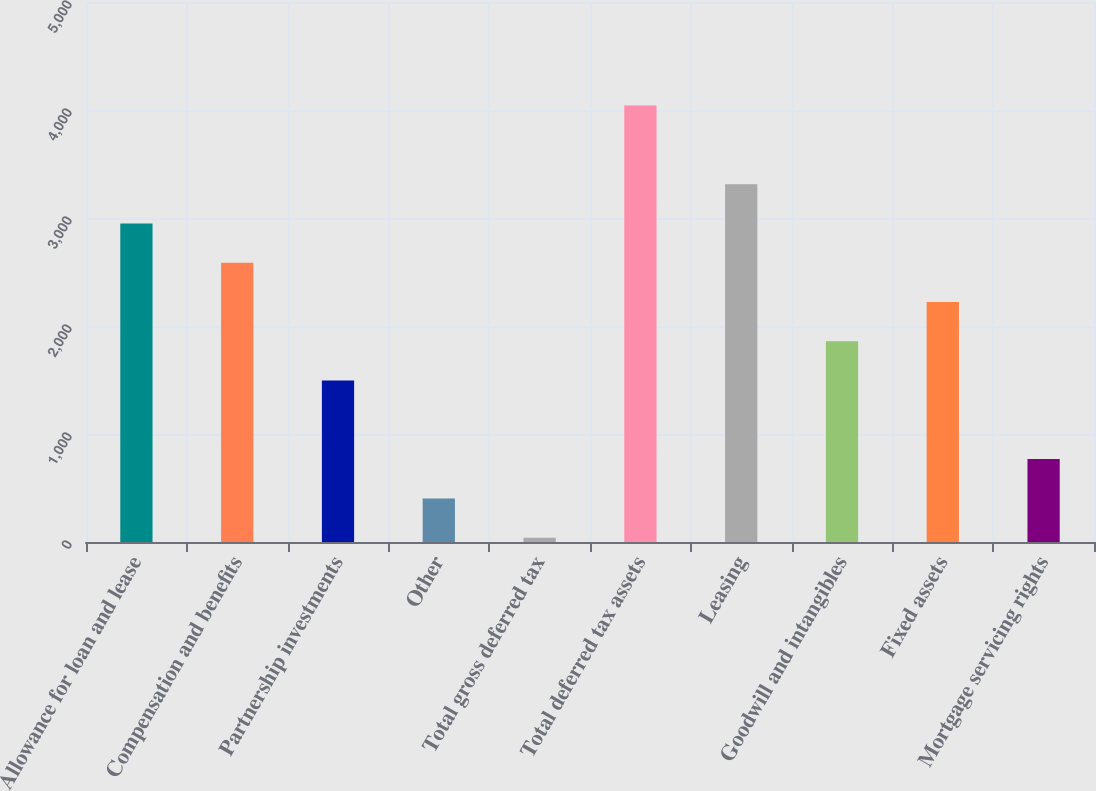Convert chart to OTSL. <chart><loc_0><loc_0><loc_500><loc_500><bar_chart><fcel>Allowance for loan and lease<fcel>Compensation and benefits<fcel>Partnership investments<fcel>Other<fcel>Total gross deferred tax<fcel>Total deferred tax assets<fcel>Leasing<fcel>Goodwill and intangibles<fcel>Fixed assets<fcel>Mortgage servicing rights<nl><fcel>2949.6<fcel>2585.9<fcel>1494.8<fcel>403.7<fcel>40<fcel>4040.7<fcel>3313.3<fcel>1858.5<fcel>2222.2<fcel>767.4<nl></chart> 